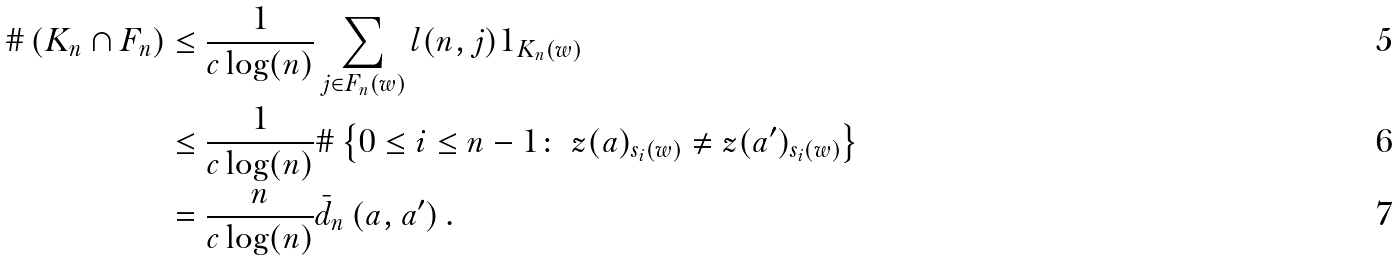Convert formula to latex. <formula><loc_0><loc_0><loc_500><loc_500>\# \left ( K _ { n } \cap F _ { n } \right ) & \leq \frac { 1 } { c \log ( n ) } \sum _ { j \in F _ { n } ( w ) } l ( n , j ) 1 _ { K _ { n } ( w ) } \\ & \leq \frac { 1 } { c \log ( n ) } \# \left \{ 0 \leq i \leq n - 1 \colon \ z ( a ) _ { s _ { i } ( w ) } \neq z ( a ^ { \prime } ) _ { s _ { i } ( w ) } \right \} \\ & = \frac { n } { c \log ( n ) } \bar { d } _ { n } \left ( a , a ^ { \prime } \right ) .</formula> 